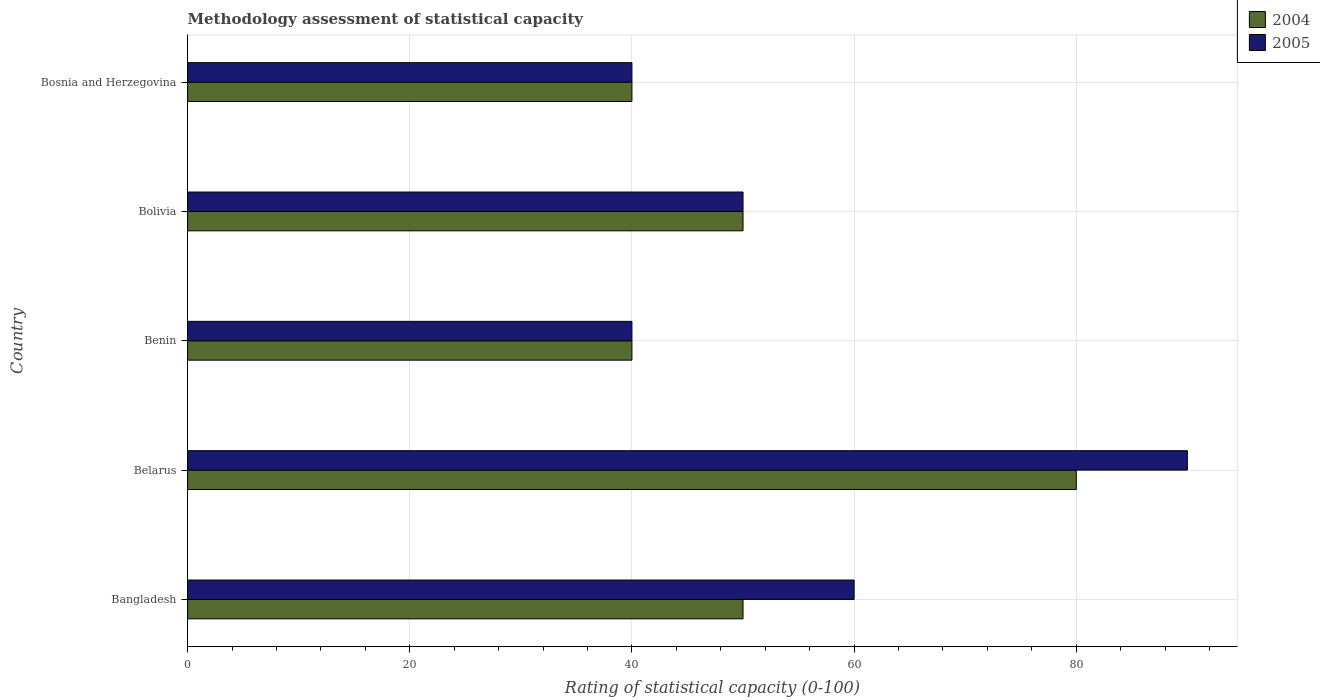How many different coloured bars are there?
Ensure brevity in your answer.  2. How many bars are there on the 2nd tick from the bottom?
Your answer should be compact. 2. What is the label of the 3rd group of bars from the top?
Offer a very short reply. Benin. In how many cases, is the number of bars for a given country not equal to the number of legend labels?
Offer a very short reply. 0. What is the rating of statistical capacity in 2004 in Bolivia?
Offer a very short reply. 50. Across all countries, what is the maximum rating of statistical capacity in 2004?
Provide a succinct answer. 80. In which country was the rating of statistical capacity in 2005 maximum?
Offer a very short reply. Belarus. In which country was the rating of statistical capacity in 2005 minimum?
Ensure brevity in your answer.  Benin. What is the total rating of statistical capacity in 2004 in the graph?
Your answer should be very brief. 260. What is the difference between the rating of statistical capacity in 2004 and rating of statistical capacity in 2005 in Benin?
Your response must be concise. 0. In how many countries, is the rating of statistical capacity in 2004 greater than 72 ?
Your response must be concise. 1. What is the ratio of the rating of statistical capacity in 2005 in Belarus to that in Bosnia and Herzegovina?
Your answer should be very brief. 2.25. Is the difference between the rating of statistical capacity in 2004 in Benin and Bolivia greater than the difference between the rating of statistical capacity in 2005 in Benin and Bolivia?
Make the answer very short. No. What is the difference between the highest and the second highest rating of statistical capacity in 2004?
Keep it short and to the point. 30. What does the 2nd bar from the top in Bolivia represents?
Your response must be concise. 2004. How many bars are there?
Your answer should be compact. 10. How many countries are there in the graph?
Offer a very short reply. 5. Where does the legend appear in the graph?
Your response must be concise. Top right. How many legend labels are there?
Give a very brief answer. 2. How are the legend labels stacked?
Your answer should be compact. Vertical. What is the title of the graph?
Ensure brevity in your answer.  Methodology assessment of statistical capacity. Does "1993" appear as one of the legend labels in the graph?
Your answer should be very brief. No. What is the label or title of the X-axis?
Your response must be concise. Rating of statistical capacity (0-100). What is the label or title of the Y-axis?
Provide a succinct answer. Country. What is the Rating of statistical capacity (0-100) of 2004 in Bangladesh?
Your answer should be compact. 50. What is the Rating of statistical capacity (0-100) of 2005 in Bangladesh?
Offer a very short reply. 60. What is the Rating of statistical capacity (0-100) of 2005 in Benin?
Make the answer very short. 40. What is the Rating of statistical capacity (0-100) of 2004 in Bolivia?
Offer a very short reply. 50. What is the Rating of statistical capacity (0-100) in 2005 in Bosnia and Herzegovina?
Offer a very short reply. 40. Across all countries, what is the maximum Rating of statistical capacity (0-100) of 2004?
Your answer should be compact. 80. What is the total Rating of statistical capacity (0-100) in 2004 in the graph?
Give a very brief answer. 260. What is the total Rating of statistical capacity (0-100) of 2005 in the graph?
Your answer should be very brief. 280. What is the difference between the Rating of statistical capacity (0-100) in 2004 in Bangladesh and that in Belarus?
Keep it short and to the point. -30. What is the difference between the Rating of statistical capacity (0-100) of 2004 in Bangladesh and that in Benin?
Make the answer very short. 10. What is the difference between the Rating of statistical capacity (0-100) of 2004 in Belarus and that in Benin?
Offer a very short reply. 40. What is the difference between the Rating of statistical capacity (0-100) of 2005 in Belarus and that in Benin?
Your response must be concise. 50. What is the difference between the Rating of statistical capacity (0-100) in 2005 in Belarus and that in Bolivia?
Your answer should be very brief. 40. What is the difference between the Rating of statistical capacity (0-100) in 2005 in Belarus and that in Bosnia and Herzegovina?
Your response must be concise. 50. What is the difference between the Rating of statistical capacity (0-100) in 2004 in Benin and that in Bolivia?
Provide a short and direct response. -10. What is the difference between the Rating of statistical capacity (0-100) of 2004 in Benin and that in Bosnia and Herzegovina?
Keep it short and to the point. 0. What is the difference between the Rating of statistical capacity (0-100) of 2005 in Benin and that in Bosnia and Herzegovina?
Your answer should be very brief. 0. What is the difference between the Rating of statistical capacity (0-100) of 2004 in Bangladesh and the Rating of statistical capacity (0-100) of 2005 in Belarus?
Your answer should be compact. -40. What is the difference between the Rating of statistical capacity (0-100) of 2004 in Belarus and the Rating of statistical capacity (0-100) of 2005 in Benin?
Your answer should be very brief. 40. What is the difference between the Rating of statistical capacity (0-100) of 2004 in Belarus and the Rating of statistical capacity (0-100) of 2005 in Bosnia and Herzegovina?
Ensure brevity in your answer.  40. What is the difference between the Rating of statistical capacity (0-100) in 2004 in Benin and the Rating of statistical capacity (0-100) in 2005 in Bolivia?
Your response must be concise. -10. What is the average Rating of statistical capacity (0-100) of 2004 per country?
Provide a succinct answer. 52. What is the average Rating of statistical capacity (0-100) in 2005 per country?
Your answer should be very brief. 56. What is the difference between the Rating of statistical capacity (0-100) in 2004 and Rating of statistical capacity (0-100) in 2005 in Bangladesh?
Your answer should be compact. -10. What is the difference between the Rating of statistical capacity (0-100) in 2004 and Rating of statistical capacity (0-100) in 2005 in Benin?
Provide a short and direct response. 0. What is the ratio of the Rating of statistical capacity (0-100) of 2004 in Bangladesh to that in Belarus?
Your response must be concise. 0.62. What is the ratio of the Rating of statistical capacity (0-100) of 2005 in Bangladesh to that in Benin?
Your answer should be very brief. 1.5. What is the ratio of the Rating of statistical capacity (0-100) in 2004 in Bangladesh to that in Bosnia and Herzegovina?
Your answer should be very brief. 1.25. What is the ratio of the Rating of statistical capacity (0-100) of 2005 in Bangladesh to that in Bosnia and Herzegovina?
Make the answer very short. 1.5. What is the ratio of the Rating of statistical capacity (0-100) of 2005 in Belarus to that in Benin?
Ensure brevity in your answer.  2.25. What is the ratio of the Rating of statistical capacity (0-100) of 2005 in Belarus to that in Bosnia and Herzegovina?
Provide a succinct answer. 2.25. What is the ratio of the Rating of statistical capacity (0-100) in 2004 in Benin to that in Bosnia and Herzegovina?
Your answer should be very brief. 1. What is the ratio of the Rating of statistical capacity (0-100) in 2005 in Benin to that in Bosnia and Herzegovina?
Give a very brief answer. 1. What is the ratio of the Rating of statistical capacity (0-100) of 2005 in Bolivia to that in Bosnia and Herzegovina?
Ensure brevity in your answer.  1.25. What is the difference between the highest and the second highest Rating of statistical capacity (0-100) in 2005?
Offer a terse response. 30. What is the difference between the highest and the lowest Rating of statistical capacity (0-100) in 2004?
Offer a terse response. 40. 